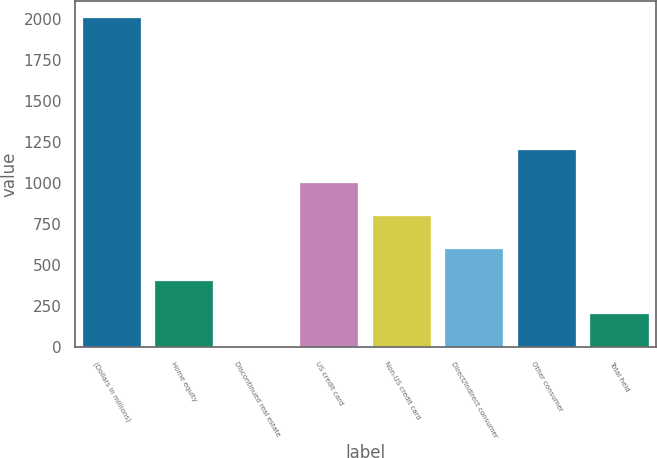<chart> <loc_0><loc_0><loc_500><loc_500><bar_chart><fcel>(Dollars in millions)<fcel>Home equity<fcel>Discontinued real estate<fcel>US credit card<fcel>Non-US credit card<fcel>Direct/Indirect consumer<fcel>Other consumer<fcel>Total held<nl><fcel>2009<fcel>402.26<fcel>0.58<fcel>1004.78<fcel>803.94<fcel>603.1<fcel>1205.62<fcel>201.42<nl></chart> 